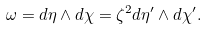Convert formula to latex. <formula><loc_0><loc_0><loc_500><loc_500>\omega = d \eta \wedge d \chi = \zeta ^ { 2 } d \eta ^ { \prime } \wedge d \chi ^ { \prime } .</formula> 